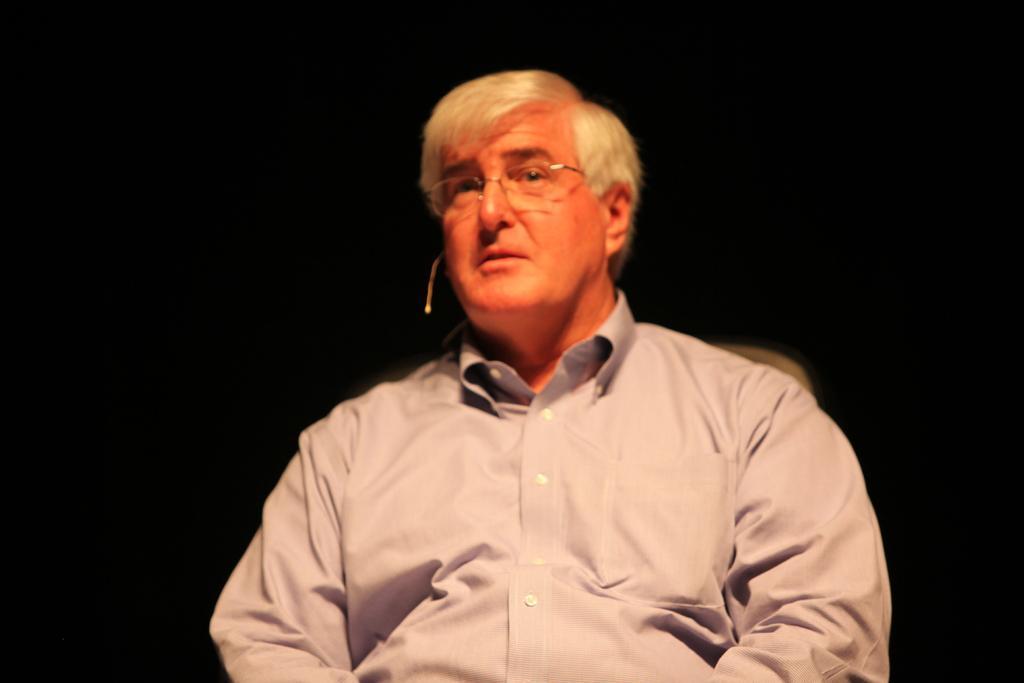How would you summarize this image in a sentence or two? In the picture we can see a man sitting on the chair and he is in shirt and white hair and behind him we can see the dark. 